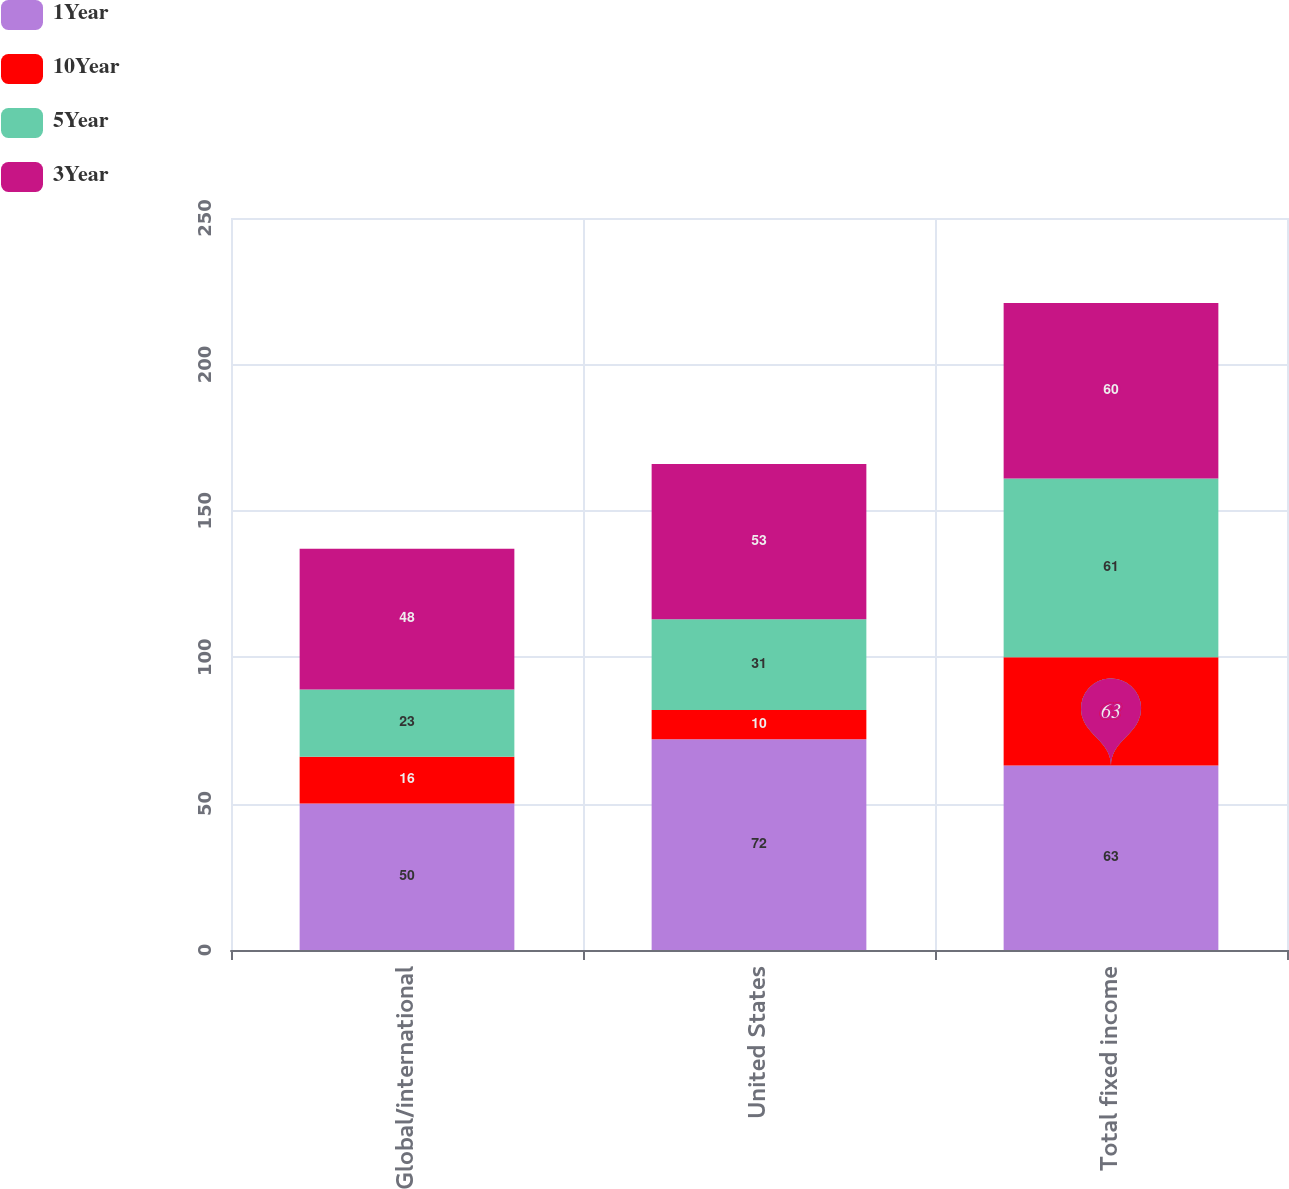Convert chart to OTSL. <chart><loc_0><loc_0><loc_500><loc_500><stacked_bar_chart><ecel><fcel>Global/international<fcel>United States<fcel>Total fixed income<nl><fcel>1Year<fcel>50<fcel>72<fcel>63<nl><fcel>10Year<fcel>16<fcel>10<fcel>37<nl><fcel>5Year<fcel>23<fcel>31<fcel>61<nl><fcel>3Year<fcel>48<fcel>53<fcel>60<nl></chart> 